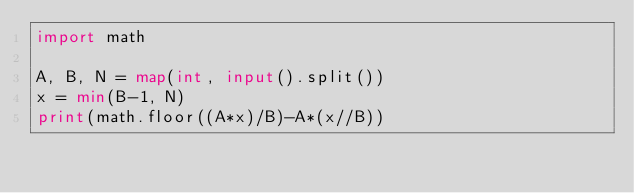<code> <loc_0><loc_0><loc_500><loc_500><_Python_>import math

A, B, N = map(int, input().split())
x = min(B-1, N)
print(math.floor((A*x)/B)-A*(x//B))
</code> 